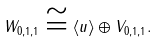<formula> <loc_0><loc_0><loc_500><loc_500>W _ { 0 , 1 , 1 } \cong \langle u \rangle \oplus V _ { 0 , 1 , 1 } .</formula> 